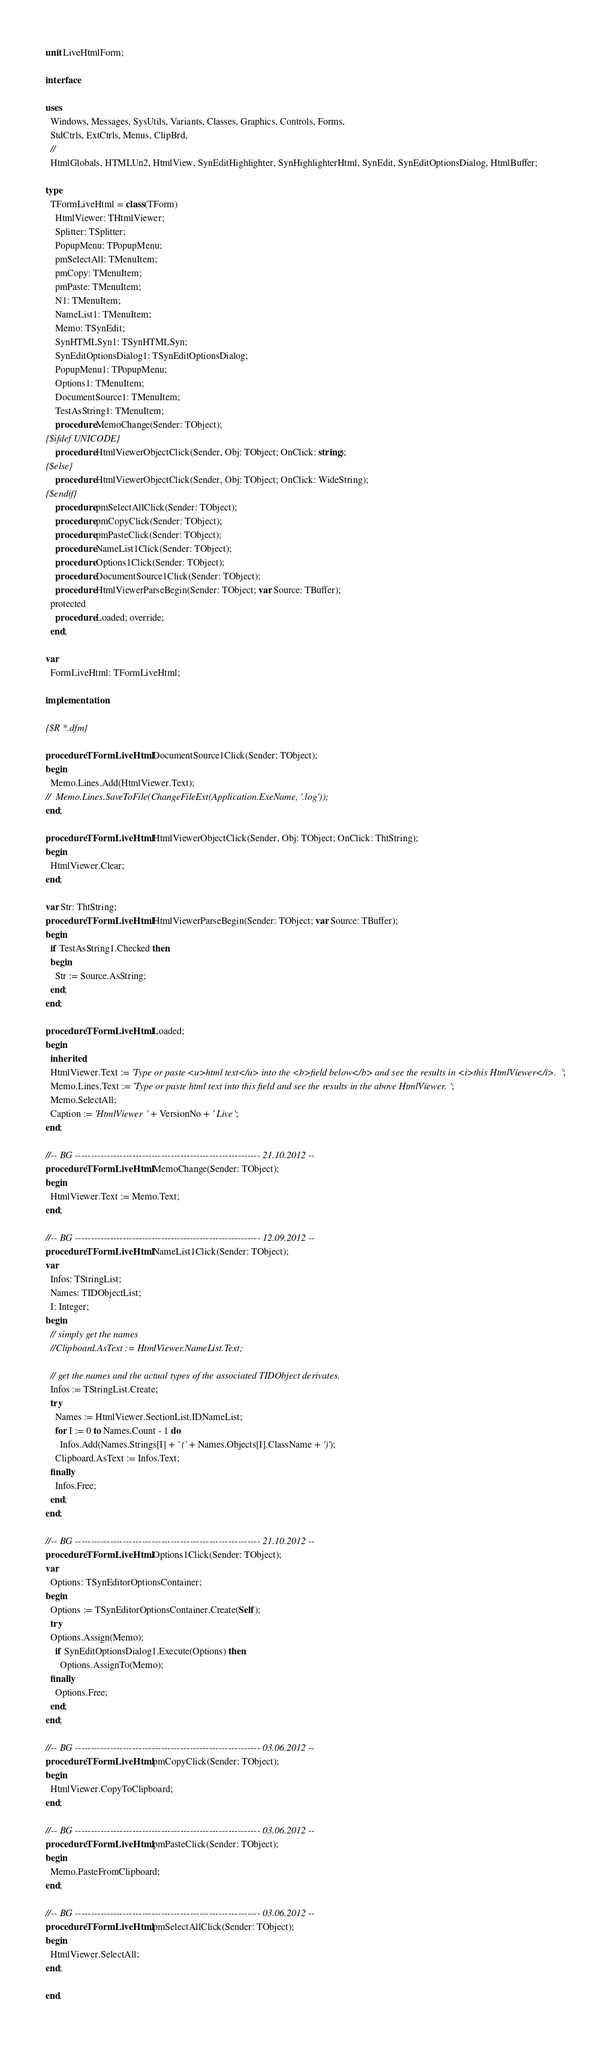<code> <loc_0><loc_0><loc_500><loc_500><_Pascal_>unit LiveHtmlForm;

interface

uses
  Windows, Messages, SysUtils, Variants, Classes, Graphics, Controls, Forms,
  StdCtrls, ExtCtrls, Menus, ClipBrd,
  //
  HtmlGlobals, HTMLUn2, HtmlView, SynEditHighlighter, SynHighlighterHtml, SynEdit, SynEditOptionsDialog, HtmlBuffer;

type
  TFormLiveHtml = class(TForm)
    HtmlViewer: THtmlViewer;
    Splitter: TSplitter;
    PopupMenu: TPopupMenu;
    pmSelectAll: TMenuItem;
    pmCopy: TMenuItem;
    pmPaste: TMenuItem;
    N1: TMenuItem;
    NameList1: TMenuItem;
    Memo: TSynEdit;
    SynHTMLSyn1: TSynHTMLSyn;
    SynEditOptionsDialog1: TSynEditOptionsDialog;
    PopupMenu1: TPopupMenu;
    Options1: TMenuItem;
    DocumentSource1: TMenuItem;
    TestAsString1: TMenuItem;
    procedure MemoChange(Sender: TObject);
{$ifdef UNICODE}
    procedure HtmlViewerObjectClick(Sender, Obj: TObject; OnClick: string);
{$else}
    procedure HtmlViewerObjectClick(Sender, Obj: TObject; OnClick: WideString);
{$endif}
    procedure pmSelectAllClick(Sender: TObject);
    procedure pmCopyClick(Sender: TObject);
    procedure pmPasteClick(Sender: TObject);
    procedure NameList1Click(Sender: TObject);
    procedure Options1Click(Sender: TObject);
    procedure DocumentSource1Click(Sender: TObject);
    procedure HtmlViewerParseBegin(Sender: TObject; var Source: TBuffer);
  protected
    procedure Loaded; override;
  end;

var
  FormLiveHtml: TFormLiveHtml;

implementation

{$R *.dfm}

procedure TFormLiveHtml.DocumentSource1Click(Sender: TObject);
begin
  Memo.Lines.Add(HtmlViewer.Text);
//  Memo.Lines.SaveToFile(ChangeFileExt(Application.ExeName, '.log'));
end;

procedure TFormLiveHtml.HtmlViewerObjectClick(Sender, Obj: TObject; OnClick: ThtString);
begin
  HtmlViewer.Clear;
end;

var Str: ThtString;
procedure TFormLiveHtml.HtmlViewerParseBegin(Sender: TObject; var Source: TBuffer);
begin
  if TestAsString1.Checked then
  begin
    Str := Source.AsString;
  end;
end;

procedure TFormLiveHtml.Loaded;
begin
  inherited;
  HtmlViewer.Text := 'Type or paste <u>html text</u> into the <b>field below</b> and see the results in <i>this HtmlViewer</i>.';
  Memo.Lines.Text := 'Type or paste html text into this field and see the results in the above HtmlViewer.';
  Memo.SelectAll;
  Caption := 'HtmlViewer ' + VersionNo + ' Live';
end;

//-- BG ---------------------------------------------------------- 21.10.2012 --
procedure TFormLiveHtml.MemoChange(Sender: TObject);
begin
  HtmlViewer.Text := Memo.Text;
end;

//-- BG ---------------------------------------------------------- 12.09.2012 --
procedure TFormLiveHtml.NameList1Click(Sender: TObject);
var
  Infos: TStringList;
  Names: TIDObjectList;
  I: Integer;
begin
  // simply get the names
  //Clipboard.AsText := HtmlViewer.NameList.Text;

  // get the names and the actual types of the associated TIDObject derivates.
  Infos := TStringList.Create;
  try
    Names := HtmlViewer.SectionList.IDNameList;
    for I := 0 to Names.Count - 1 do
      Infos.Add(Names.Strings[I] + ' (' + Names.Objects[I].ClassName + ')');
    Clipboard.AsText := Infos.Text;
  finally
    Infos.Free;
  end;
end;

//-- BG ---------------------------------------------------------- 21.10.2012 --
procedure TFormLiveHtml.Options1Click(Sender: TObject);
var
  Options: TSynEditorOptionsContainer;
begin
  Options := TSynEditorOptionsContainer.Create(Self);
  try
  Options.Assign(Memo);
    if SynEditOptionsDialog1.Execute(Options) then
      Options.AssignTo(Memo);
  finally
    Options.Free;
  end;
end;

//-- BG ---------------------------------------------------------- 03.06.2012 --
procedure TFormLiveHtml.pmCopyClick(Sender: TObject);
begin
  HtmlViewer.CopyToClipboard;
end;

//-- BG ---------------------------------------------------------- 03.06.2012 --
procedure TFormLiveHtml.pmPasteClick(Sender: TObject);
begin
  Memo.PasteFromClipboard;
end;

//-- BG ---------------------------------------------------------- 03.06.2012 --
procedure TFormLiveHtml.pmSelectAllClick(Sender: TObject);
begin
  HtmlViewer.SelectAll;
end;

end.
</code> 